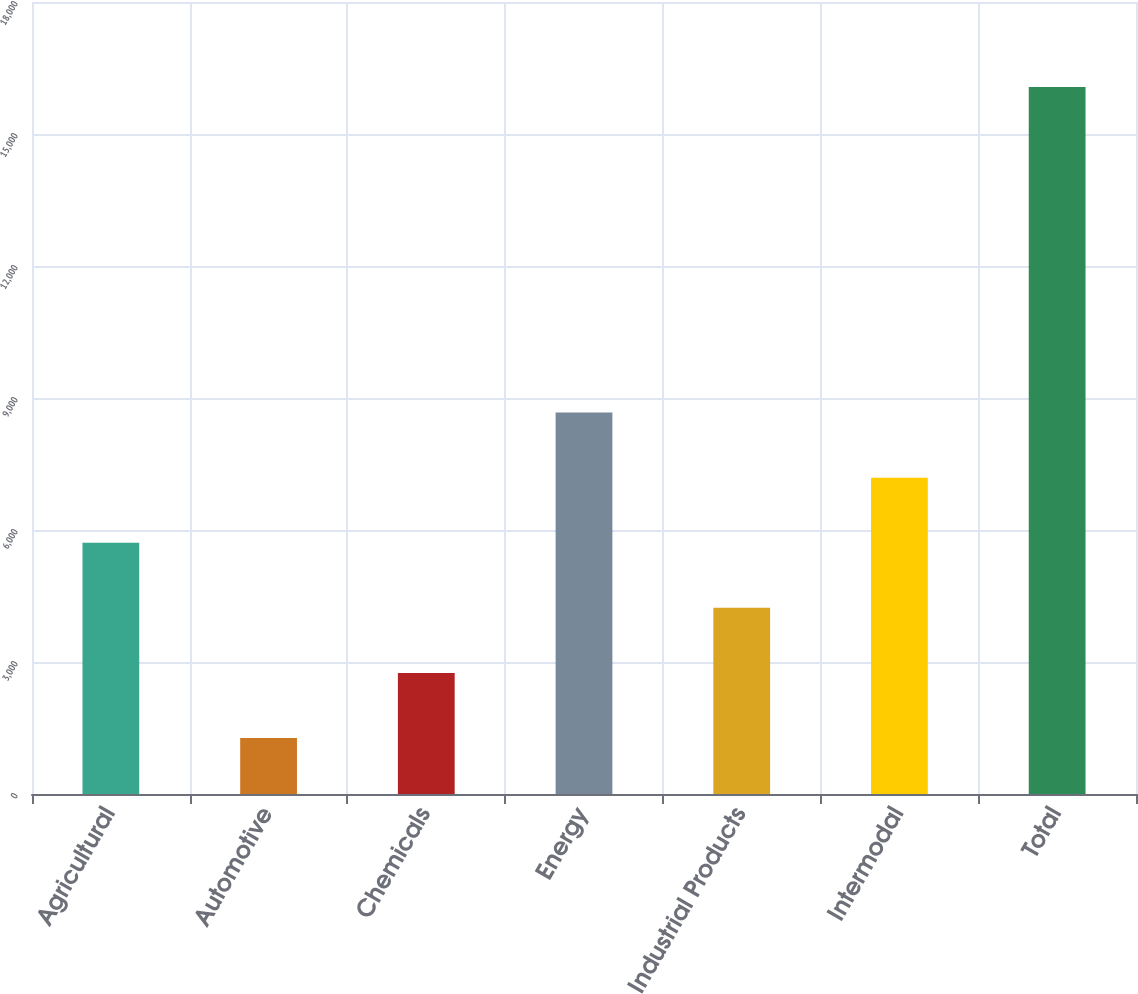Convert chart. <chart><loc_0><loc_0><loc_500><loc_500><bar_chart><fcel>Agricultural<fcel>Automotive<fcel>Chemicals<fcel>Energy<fcel>Industrial Products<fcel>Intermodal<fcel>Total<nl><fcel>5710.4<fcel>1271<fcel>2750.8<fcel>8670<fcel>4230.6<fcel>7190.2<fcel>16069<nl></chart> 